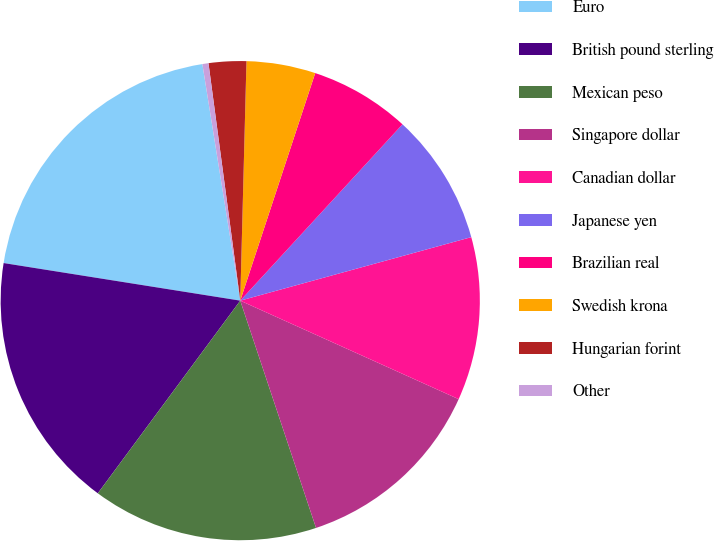Convert chart to OTSL. <chart><loc_0><loc_0><loc_500><loc_500><pie_chart><fcel>Euro<fcel>British pound sterling<fcel>Mexican peso<fcel>Singapore dollar<fcel>Canadian dollar<fcel>Japanese yen<fcel>Brazilian real<fcel>Swedish krona<fcel>Hungarian forint<fcel>Other<nl><fcel>19.96%<fcel>17.37%<fcel>15.25%<fcel>13.13%<fcel>11.01%<fcel>8.89%<fcel>6.77%<fcel>4.65%<fcel>2.53%<fcel>0.41%<nl></chart> 